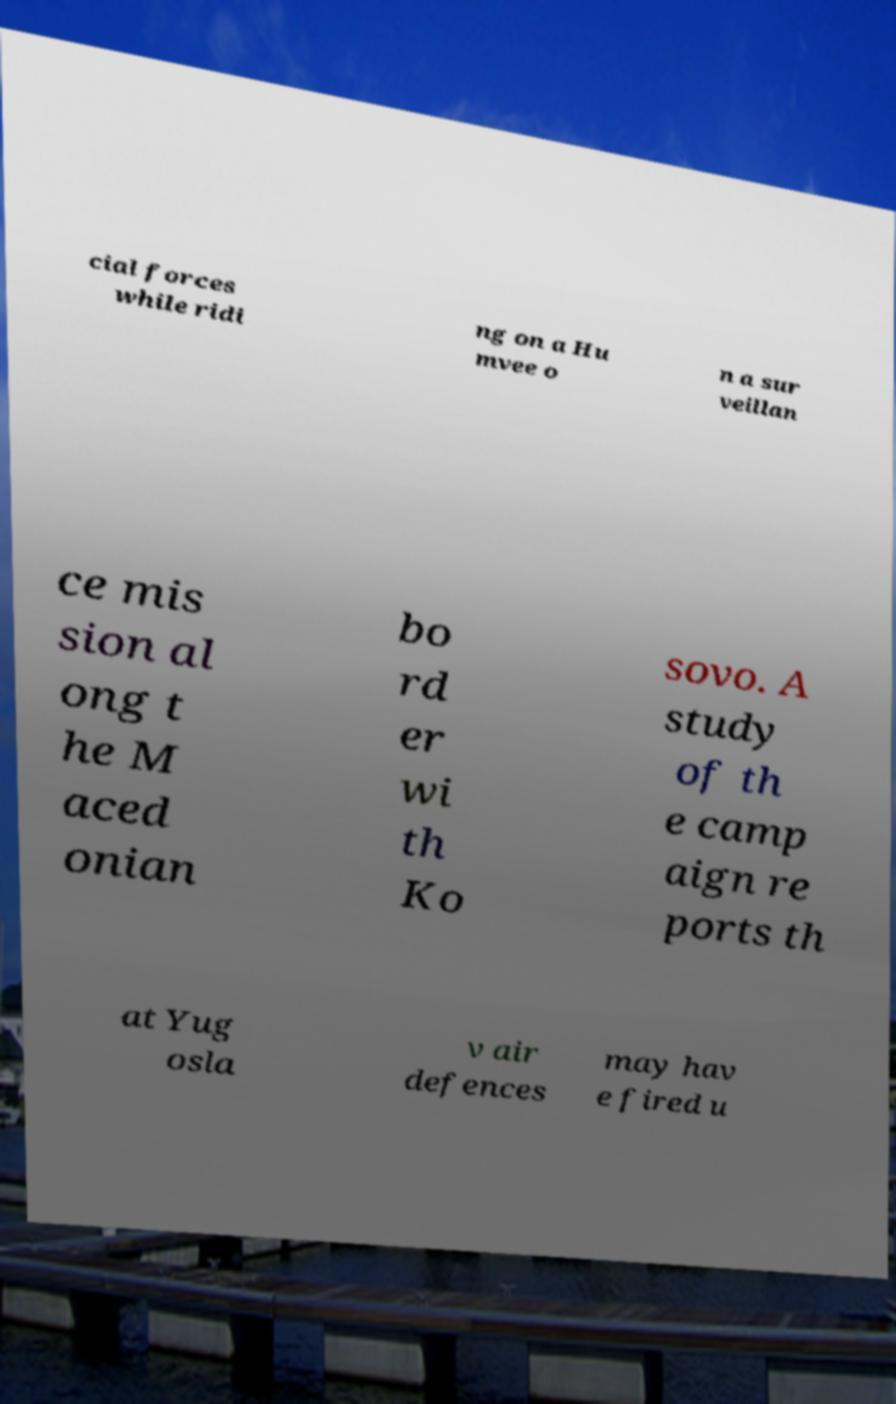Please identify and transcribe the text found in this image. cial forces while ridi ng on a Hu mvee o n a sur veillan ce mis sion al ong t he M aced onian bo rd er wi th Ko sovo. A study of th e camp aign re ports th at Yug osla v air defences may hav e fired u 